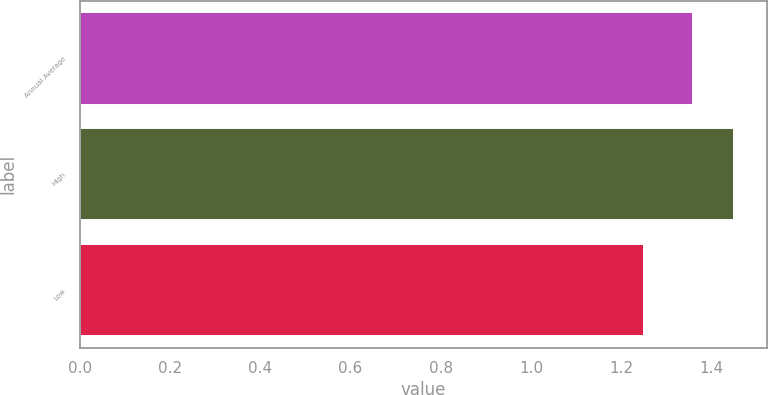<chart> <loc_0><loc_0><loc_500><loc_500><bar_chart><fcel>Annual Average<fcel>High<fcel>Low<nl><fcel>1.36<fcel>1.45<fcel>1.25<nl></chart> 